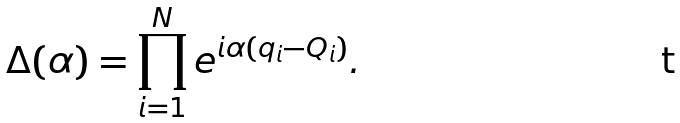Convert formula to latex. <formula><loc_0><loc_0><loc_500><loc_500>\Delta ( \alpha ) = \prod _ { i = 1 } ^ { N } e ^ { i \alpha ( q _ { i } - Q _ { i } ) } .</formula> 